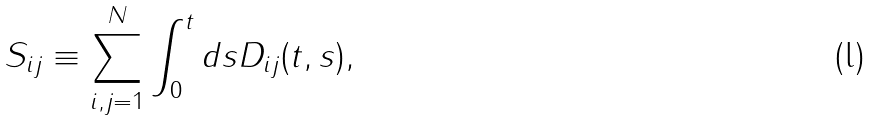<formula> <loc_0><loc_0><loc_500><loc_500>S _ { i j } \equiv \sum _ { i , j = 1 } ^ { N } \int _ { 0 } ^ { t } d s D _ { i j } ( t , s ) ,</formula> 